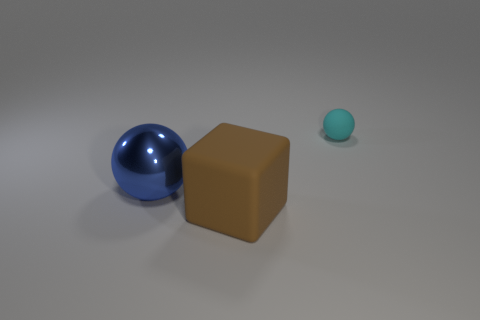Add 2 small spheres. How many objects exist? 5 Subtract all blocks. How many objects are left? 2 Subtract all big blue metal spheres. Subtract all large blue balls. How many objects are left? 1 Add 2 large balls. How many large balls are left? 3 Add 1 large metallic balls. How many large metallic balls exist? 2 Subtract 0 red cylinders. How many objects are left? 3 